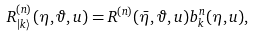Convert formula to latex. <formula><loc_0><loc_0><loc_500><loc_500>R _ { | k \rangle } ^ { ( n ) } ( \eta , \vartheta , u ) = R ^ { ( n ) } ( \bar { \eta } , \vartheta , u ) b _ { k } ^ { n } ( \eta , u ) ,</formula> 